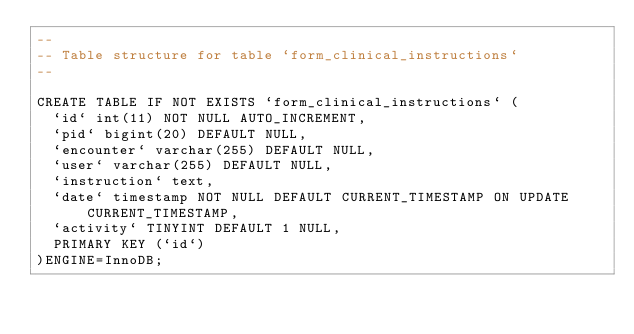Convert code to text. <code><loc_0><loc_0><loc_500><loc_500><_SQL_>--
-- Table structure for table `form_clinical_instructions`
--

CREATE TABLE IF NOT EXISTS `form_clinical_instructions` (
  `id` int(11) NOT NULL AUTO_INCREMENT,
  `pid` bigint(20) DEFAULT NULL,
  `encounter` varchar(255) DEFAULT NULL,
  `user` varchar(255) DEFAULT NULL,
  `instruction` text,
  `date` timestamp NOT NULL DEFAULT CURRENT_TIMESTAMP ON UPDATE CURRENT_TIMESTAMP,
  `activity` TINYINT DEFAULT 1 NULL,
  PRIMARY KEY (`id`)
)ENGINE=InnoDB;

</code> 